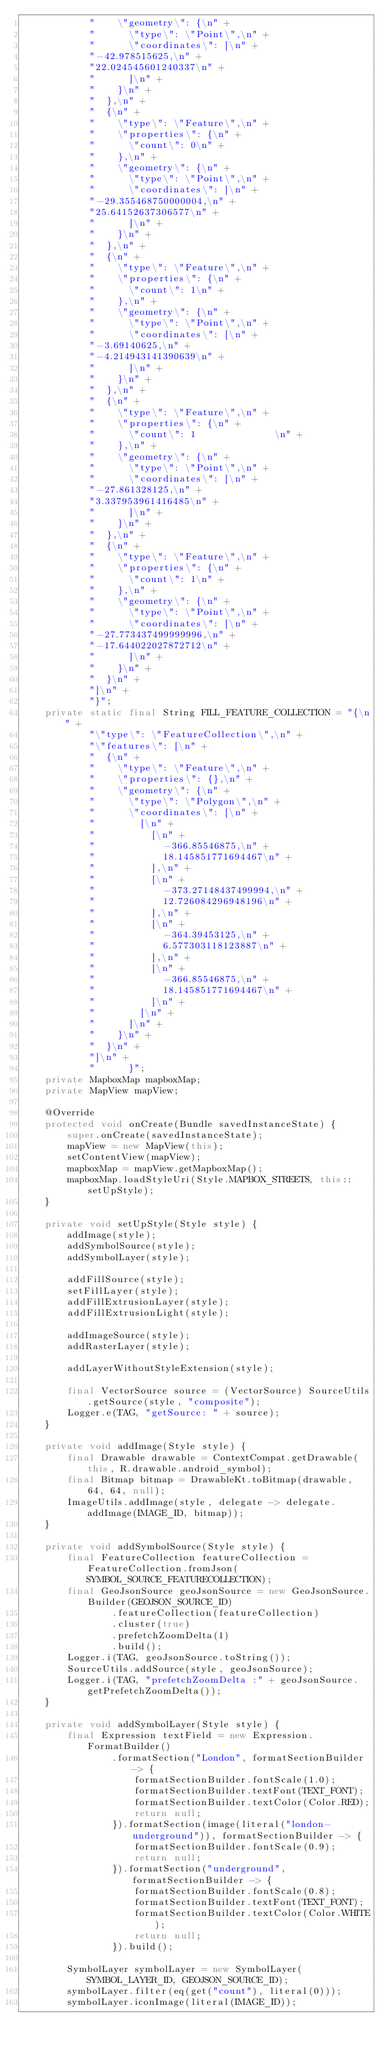<code> <loc_0><loc_0><loc_500><loc_500><_Java_>            "    \"geometry\": {\n" +
            "      \"type\": \"Point\",\n" +
            "      \"coordinates\": [\n" +
            "-42.978515625,\n" +
            "22.024545601240337\n" +
            "      ]\n" +
            "    }\n" +
            "  },\n" +
            "  {\n" +
            "    \"type\": \"Feature\",\n" +
            "    \"properties\": {\n" +
            "      \"count\": 0\n" +
            "    },\n" +
            "    \"geometry\": {\n" +
            "      \"type\": \"Point\",\n" +
            "      \"coordinates\": [\n" +
            "-29.355468750000004,\n" +
            "25.64152637306577\n" +
            "      ]\n" +
            "    }\n" +
            "  },\n" +
            "  {\n" +
            "    \"type\": \"Feature\",\n" +
            "    \"properties\": {\n" +
            "      \"count\": 1\n" +
            "    },\n" +
            "    \"geometry\": {\n" +
            "      \"type\": \"Point\",\n" +
            "      \"coordinates\": [\n" +
            "-3.69140625,\n" +
            "-4.214943141390639\n" +
            "      ]\n" +
            "    }\n" +
            "  },\n" +
            "  {\n" +
            "    \"type\": \"Feature\",\n" +
            "    \"properties\": {\n" +
            "      \"count\": 1              \n" +
            "    },\n" +
            "    \"geometry\": {\n" +
            "      \"type\": \"Point\",\n" +
            "      \"coordinates\": [\n" +
            "-27.861328125,\n" +
            "3.337953961416485\n" +
            "      ]\n" +
            "    }\n" +
            "  },\n" +
            "  {\n" +
            "    \"type\": \"Feature\",\n" +
            "    \"properties\": {\n" +
            "      \"count\": 1\n" +
            "    },\n" +
            "    \"geometry\": {\n" +
            "      \"type\": \"Point\",\n" +
            "      \"coordinates\": [\n" +
            "-27.773437499999996,\n" +
            "-17.644022027872712\n" +
            "      ]\n" +
            "    }\n" +
            "  }\n" +
            "]\n" +
            "}";
    private static final String FILL_FEATURE_COLLECTION = "{\n" +
            "\"type\": \"FeatureCollection\",\n" +
            "\"features\": [\n" +
            "  {\n" +
            "    \"type\": \"Feature\",\n" +
            "    \"properties\": {},\n" +
            "    \"geometry\": {\n" +
            "      \"type\": \"Polygon\",\n" +
            "      \"coordinates\": [\n" +
            "        [\n" +
            "          [\n" +
            "            -366.85546875,\n" +
            "            18.145851771694467\n" +
            "          ],\n" +
            "          [\n" +
            "            -373.27148437499994,\n" +
            "            12.726084296948196\n" +
            "          ],\n" +
            "          [\n" +
            "            -364.39453125,\n" +
            "            6.577303118123887\n" +
            "          ],\n" +
            "          [\n" +
            "            -366.85546875,\n" +
            "            18.145851771694467\n" +
            "          ]\n" +
            "        ]\n" +
            "      ]\n" +
            "    }\n" +
            "  }\n" +
            "]\n" +
            "      }";
    private MapboxMap mapboxMap;
    private MapView mapView;

    @Override
    protected void onCreate(Bundle savedInstanceState) {
        super.onCreate(savedInstanceState);
        mapView = new MapView(this);
        setContentView(mapView);
        mapboxMap = mapView.getMapboxMap();
        mapboxMap.loadStyleUri(Style.MAPBOX_STREETS, this::setUpStyle);
    }

    private void setUpStyle(Style style) {
        addImage(style);
        addSymbolSource(style);
        addSymbolLayer(style);

        addFillSource(style);
        setFillLayer(style);
        addFillExtrusionLayer(style);
        addFillExtrusionLight(style);

        addImageSource(style);
        addRasterLayer(style);

        addLayerWithoutStyleExtension(style);

        final VectorSource source = (VectorSource) SourceUtils.getSource(style, "composite");
        Logger.e(TAG, "getSource: " + source);
    }

    private void addImage(Style style) {
        final Drawable drawable = ContextCompat.getDrawable(this, R.drawable.android_symbol);
        final Bitmap bitmap = DrawableKt.toBitmap(drawable, 64, 64, null);
        ImageUtils.addImage(style, delegate -> delegate.addImage(IMAGE_ID, bitmap));
    }

    private void addSymbolSource(Style style) {
        final FeatureCollection featureCollection = FeatureCollection.fromJson(SYMBOL_SOURCE_FEATURECOLLECTION);
        final GeoJsonSource geoJsonSource = new GeoJsonSource.Builder(GEOJSON_SOURCE_ID)
                .featureCollection(featureCollection)
                .cluster(true)
                .prefetchZoomDelta(1)
                .build();
        Logger.i(TAG, geoJsonSource.toString());
        SourceUtils.addSource(style, geoJsonSource);
        Logger.i(TAG, "prefetchZoomDelta :" + geoJsonSource.getPrefetchZoomDelta());
    }

    private void addSymbolLayer(Style style) {
        final Expression textField = new Expression.FormatBuilder()
                .formatSection("London", formatSectionBuilder -> {
                    formatSectionBuilder.fontScale(1.0);
                    formatSectionBuilder.textFont(TEXT_FONT);
                    formatSectionBuilder.textColor(Color.RED);
                    return null;
                }).formatSection(image(literal("london-underground")), formatSectionBuilder -> {
                    formatSectionBuilder.fontScale(0.9);
                    return null;
                }).formatSection("underground", formatSectionBuilder -> {
                    formatSectionBuilder.fontScale(0.8);
                    formatSectionBuilder.textFont(TEXT_FONT);
                    formatSectionBuilder.textColor(Color.WHITE);
                    return null;
                }).build();

        SymbolLayer symbolLayer = new SymbolLayer(SYMBOL_LAYER_ID, GEOJSON_SOURCE_ID);
        symbolLayer.filter(eq(get("count"), literal(0)));
        symbolLayer.iconImage(literal(IMAGE_ID));</code> 